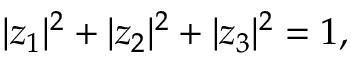Convert formula to latex. <formula><loc_0><loc_0><loc_500><loc_500>| z _ { 1 } | ^ { 2 } + | z _ { 2 } | ^ { 2 } + | z _ { 3 } | ^ { 2 } = 1 , \,</formula> 